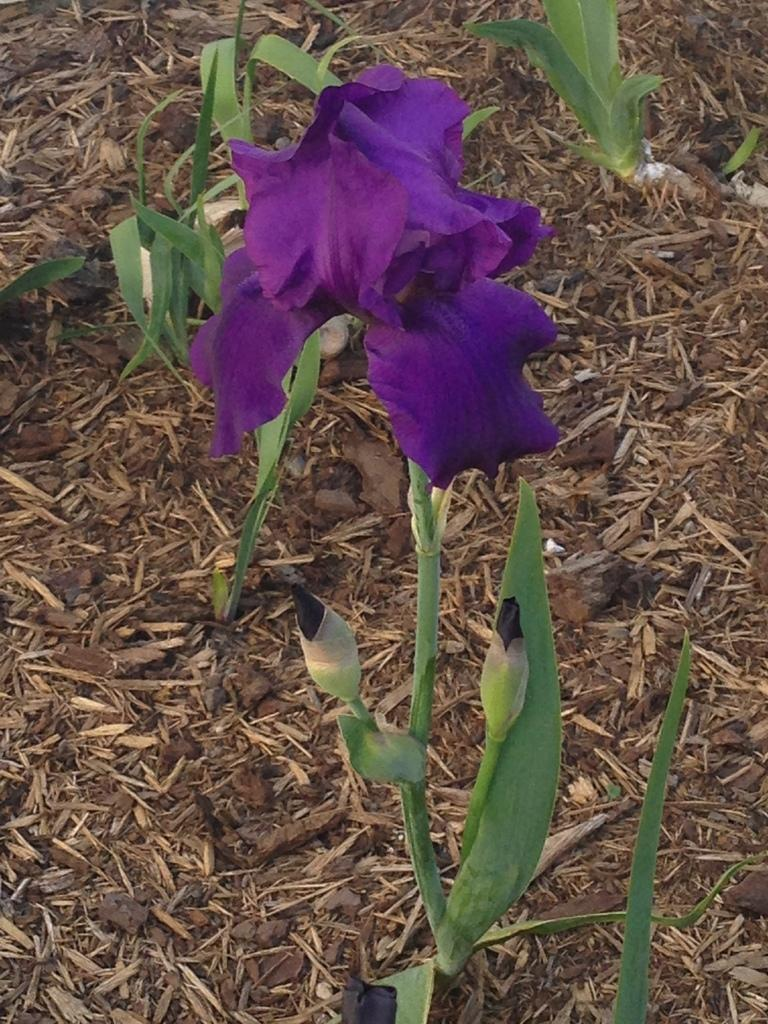What type of plant is featured in the image? There is a flower in the image. Are there any other parts of the plant visible in the image? Yes, there are buds in the image. What else can be seen in the image besides the flower and buds? There are plants in the image. What is on the ground in the background of the image? There are stones on the ground in the background of the image. What type of list is the lawyer holding during the trip in the image? There is no lawyer or trip present in the image; it features a flower, buds, plants, and stones on the ground. 